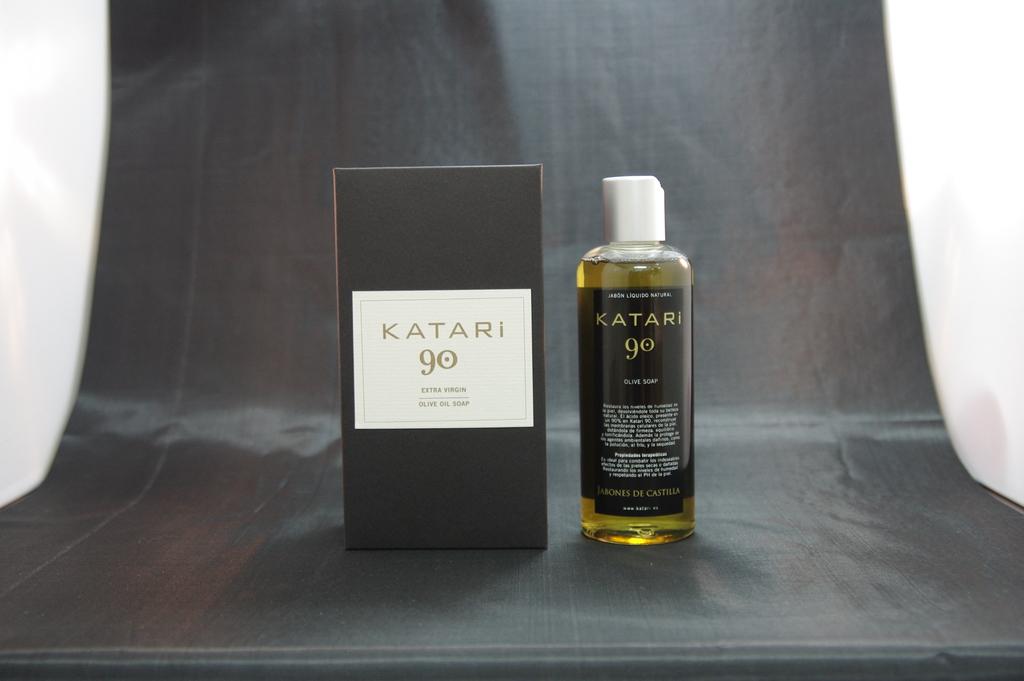What is katari?
Make the answer very short. Olive oil soap. What are the numbers on the front of the box?
Your answer should be very brief. 90. 